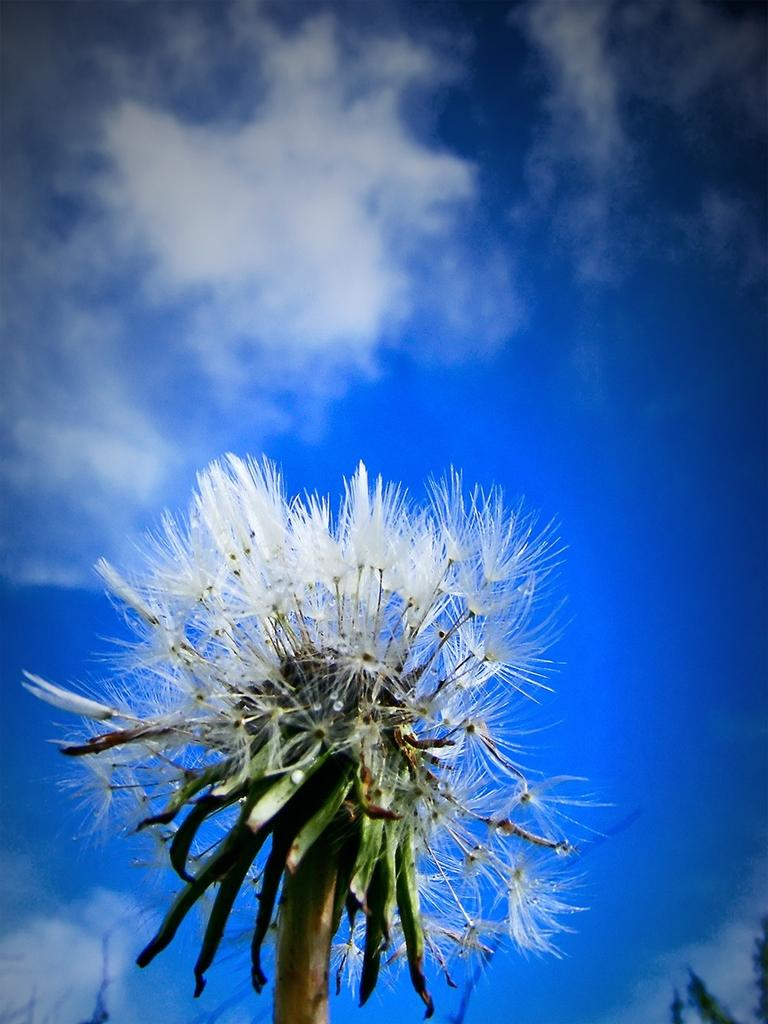Where was the image taken? The image was clicked outside the city. What can be seen in the foreground of the image? There are white color flowers and a plant in the foreground. What is visible in the background of the image? The sky is visible in the background. How many sheep are visible in the image? There are no sheep present in the image. What type of dish is the cook preparing in the image? There is no cook or dish preparation visible in the image. 